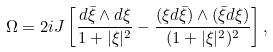<formula> <loc_0><loc_0><loc_500><loc_500>\Omega = 2 i J \left [ \frac { d { \bar { \xi } } \wedge d \xi } { 1 + | \xi | ^ { 2 } } - \frac { ( \xi d { \bar { \xi } } ) \wedge ( { \bar { \xi } } d \xi ) } { ( 1 + | \xi | ^ { 2 } ) ^ { 2 } } \right ] ,</formula> 